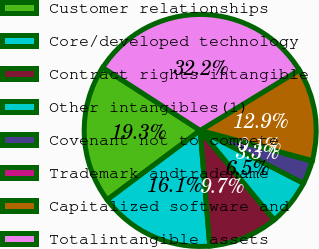<chart> <loc_0><loc_0><loc_500><loc_500><pie_chart><fcel>Customer relationships<fcel>Core/developed technology<fcel>Contract rights intangible<fcel>Other intangibles(1)<fcel>Covenant not to compete<fcel>Trademark andtradename<fcel>Capitalized software and<fcel>Totalintangible assets<nl><fcel>19.32%<fcel>16.11%<fcel>9.69%<fcel>6.48%<fcel>3.27%<fcel>0.06%<fcel>12.9%<fcel>32.17%<nl></chart> 